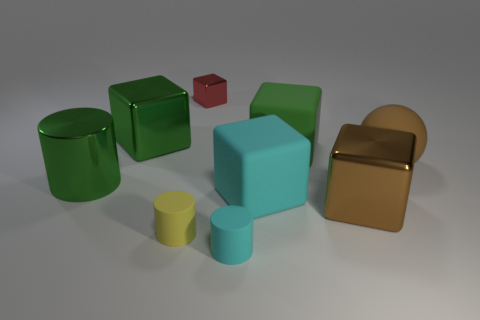What number of metal things are red cylinders or yellow cylinders?
Give a very brief answer. 0. Are there fewer purple shiny cylinders than red shiny blocks?
Offer a very short reply. Yes. Is the size of the red object the same as the cyan matte thing to the left of the big cyan cube?
Provide a succinct answer. Yes. Are there any other things that have the same shape as the large brown metallic object?
Provide a succinct answer. Yes. The metallic cylinder is what size?
Offer a terse response. Large. Is the number of tiny cyan objects to the right of the cyan matte cube less than the number of large balls?
Provide a succinct answer. Yes. Is the yellow cylinder the same size as the brown ball?
Give a very brief answer. No. Is there any other thing that is the same size as the shiny cylinder?
Your response must be concise. Yes. The cylinder that is made of the same material as the red cube is what color?
Provide a succinct answer. Green. Are there fewer small matte cylinders that are on the left side of the green shiny cylinder than large brown balls that are on the left side of the big green rubber object?
Your answer should be compact. No. 